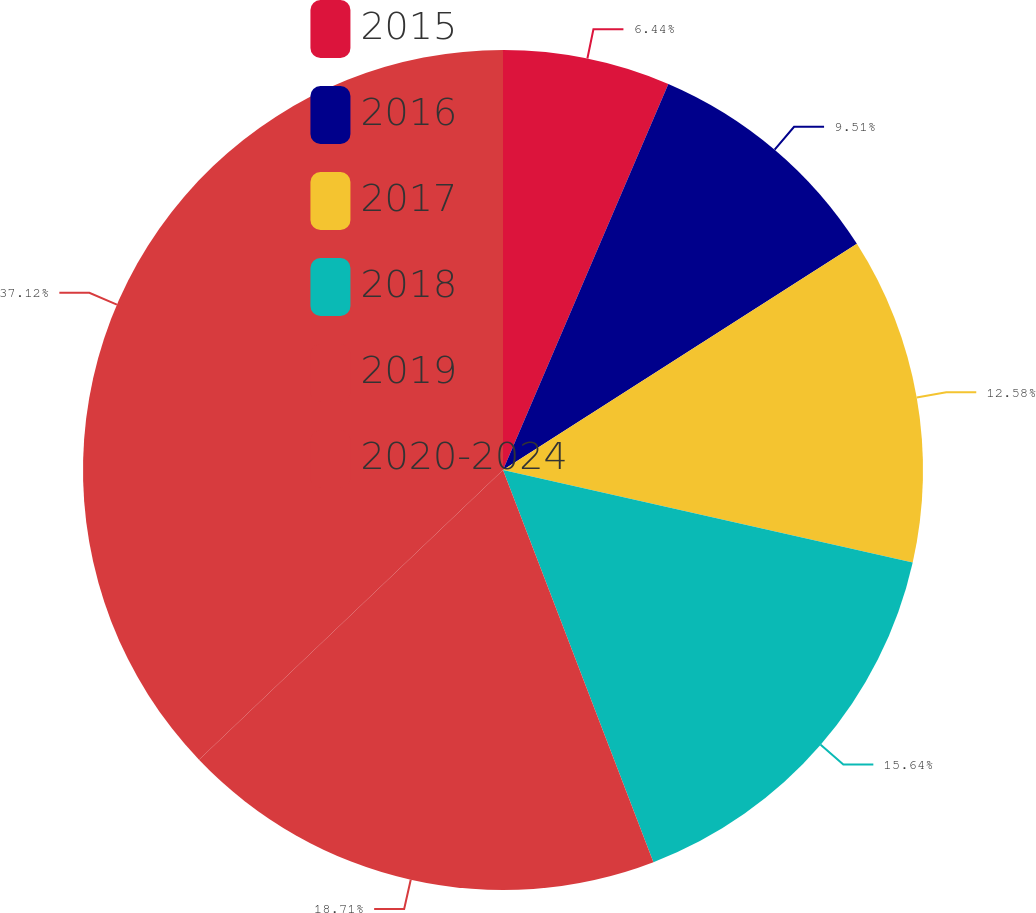Convert chart. <chart><loc_0><loc_0><loc_500><loc_500><pie_chart><fcel>2015<fcel>2016<fcel>2017<fcel>2018<fcel>2019<fcel>2020-2024<nl><fcel>6.44%<fcel>9.51%<fcel>12.58%<fcel>15.64%<fcel>18.71%<fcel>37.12%<nl></chart> 